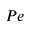<formula> <loc_0><loc_0><loc_500><loc_500>P e</formula> 